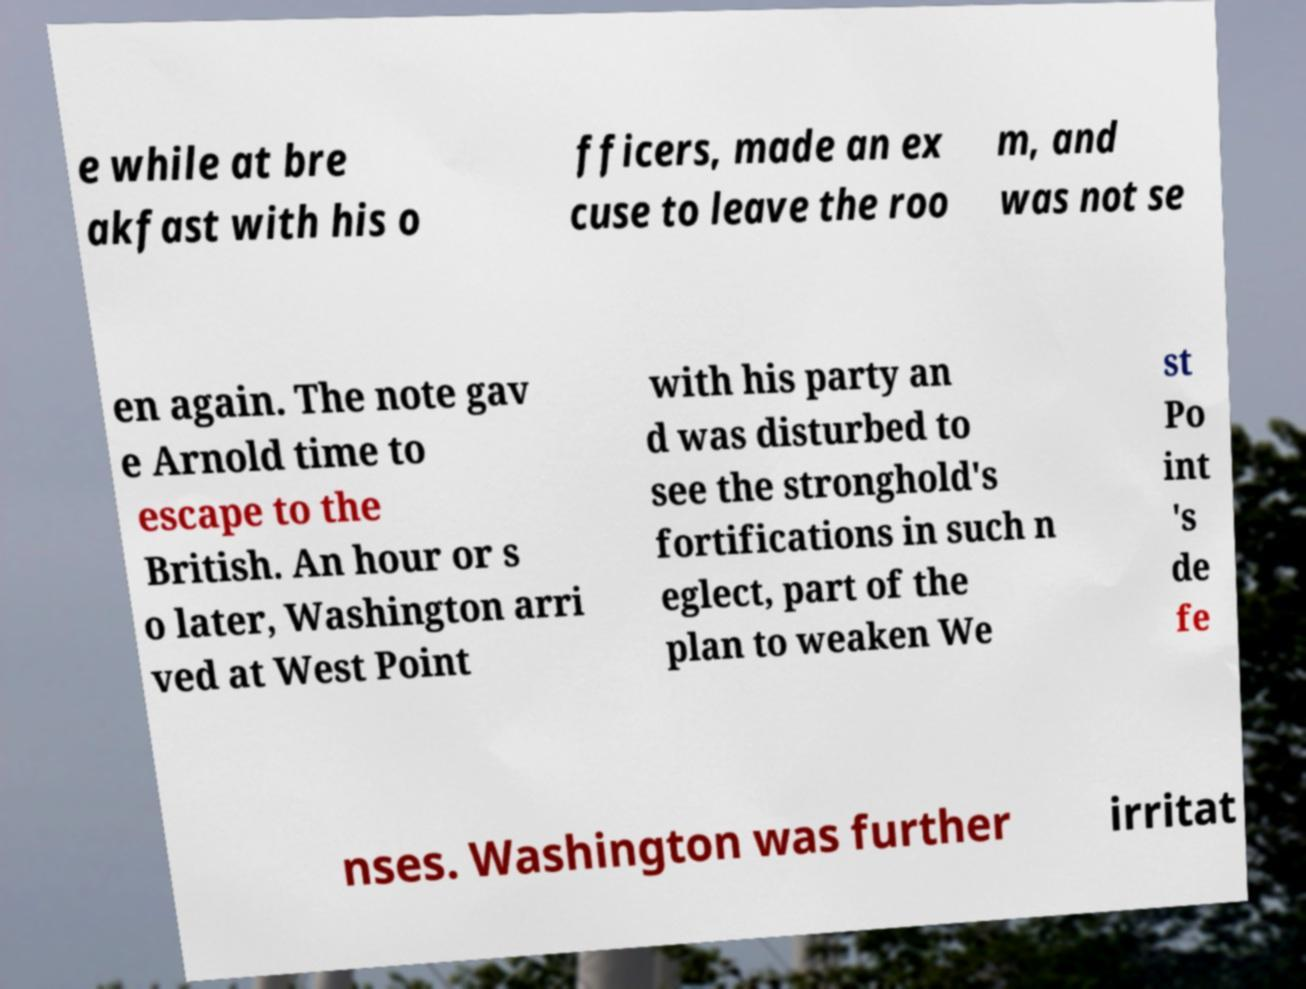Can you read and provide the text displayed in the image?This photo seems to have some interesting text. Can you extract and type it out for me? e while at bre akfast with his o fficers, made an ex cuse to leave the roo m, and was not se en again. The note gav e Arnold time to escape to the British. An hour or s o later, Washington arri ved at West Point with his party an d was disturbed to see the stronghold's fortifications in such n eglect, part of the plan to weaken We st Po int 's de fe nses. Washington was further irritat 